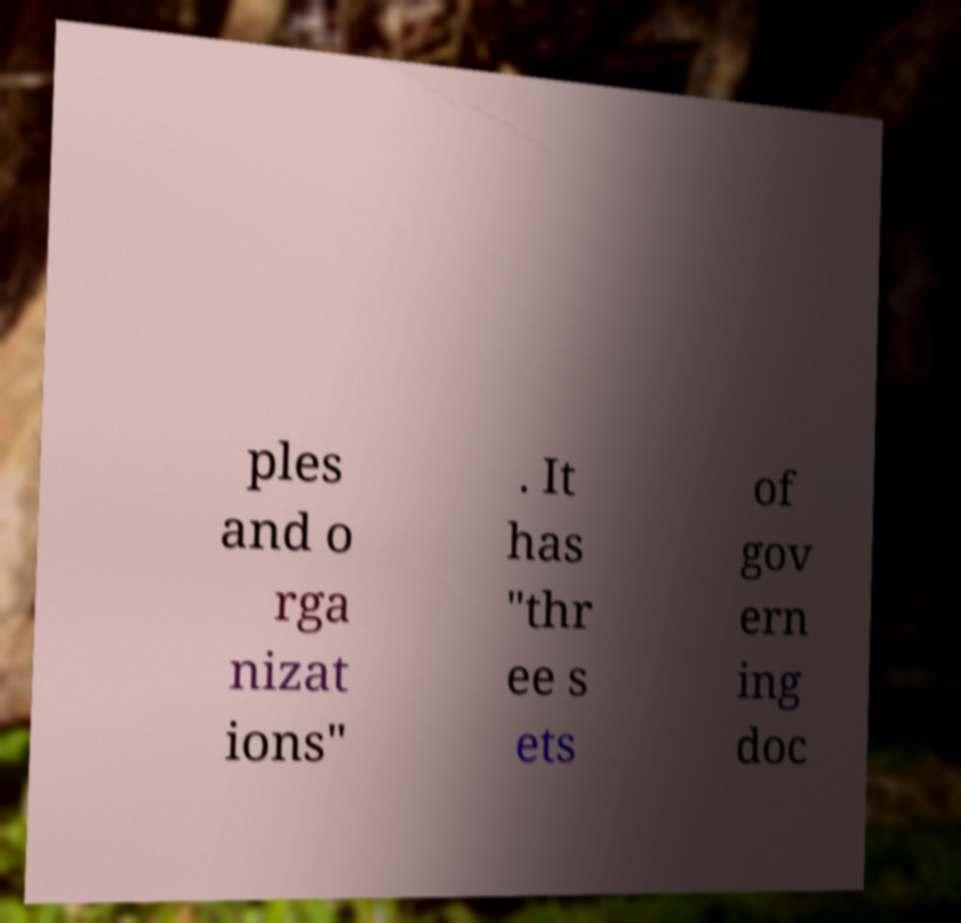Could you assist in decoding the text presented in this image and type it out clearly? ples and o rga nizat ions" . It has "thr ee s ets of gov ern ing doc 